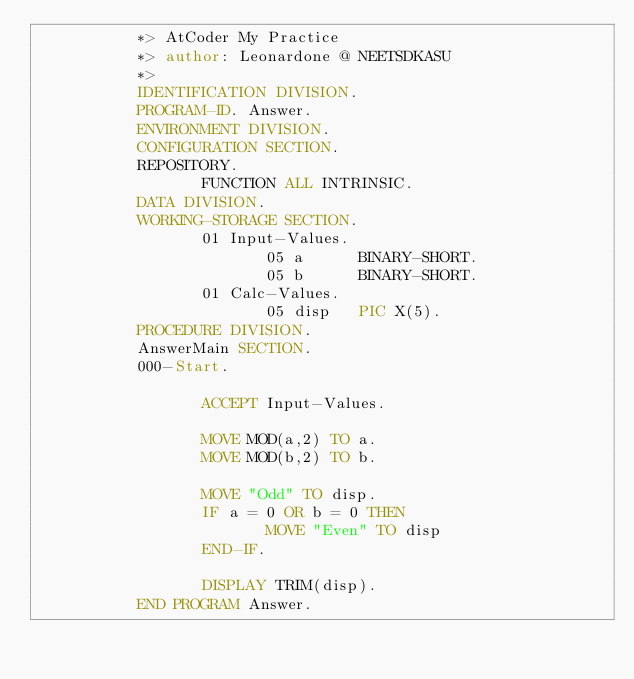Convert code to text. <code><loc_0><loc_0><loc_500><loc_500><_COBOL_>           *> AtCoder My Practice
           *> author: Leonardone @ NEETSDKASU
           *>
           IDENTIFICATION DIVISION.
           PROGRAM-ID. Answer.
           ENVIRONMENT DIVISION.
           CONFIGURATION SECTION.
           REPOSITORY.
                  FUNCTION ALL INTRINSIC.
           DATA DIVISION.
           WORKING-STORAGE SECTION.
                  01 Input-Values.
                         05 a      BINARY-SHORT.
                         05 b      BINARY-SHORT.
                  01 Calc-Values.
                         05 disp   PIC X(5).
           PROCEDURE DIVISION.
           AnswerMain SECTION.
           000-Start.
           
                  ACCEPT Input-Values.
                  
                  MOVE MOD(a,2) TO a.
                  MOVE MOD(b,2) TO b.
                  
                  MOVE "Odd" TO disp.
                  IF a = 0 OR b = 0 THEN
                         MOVE "Even" TO disp
                  END-IF.
     
                  DISPLAY TRIM(disp).
           END PROGRAM Answer.</code> 